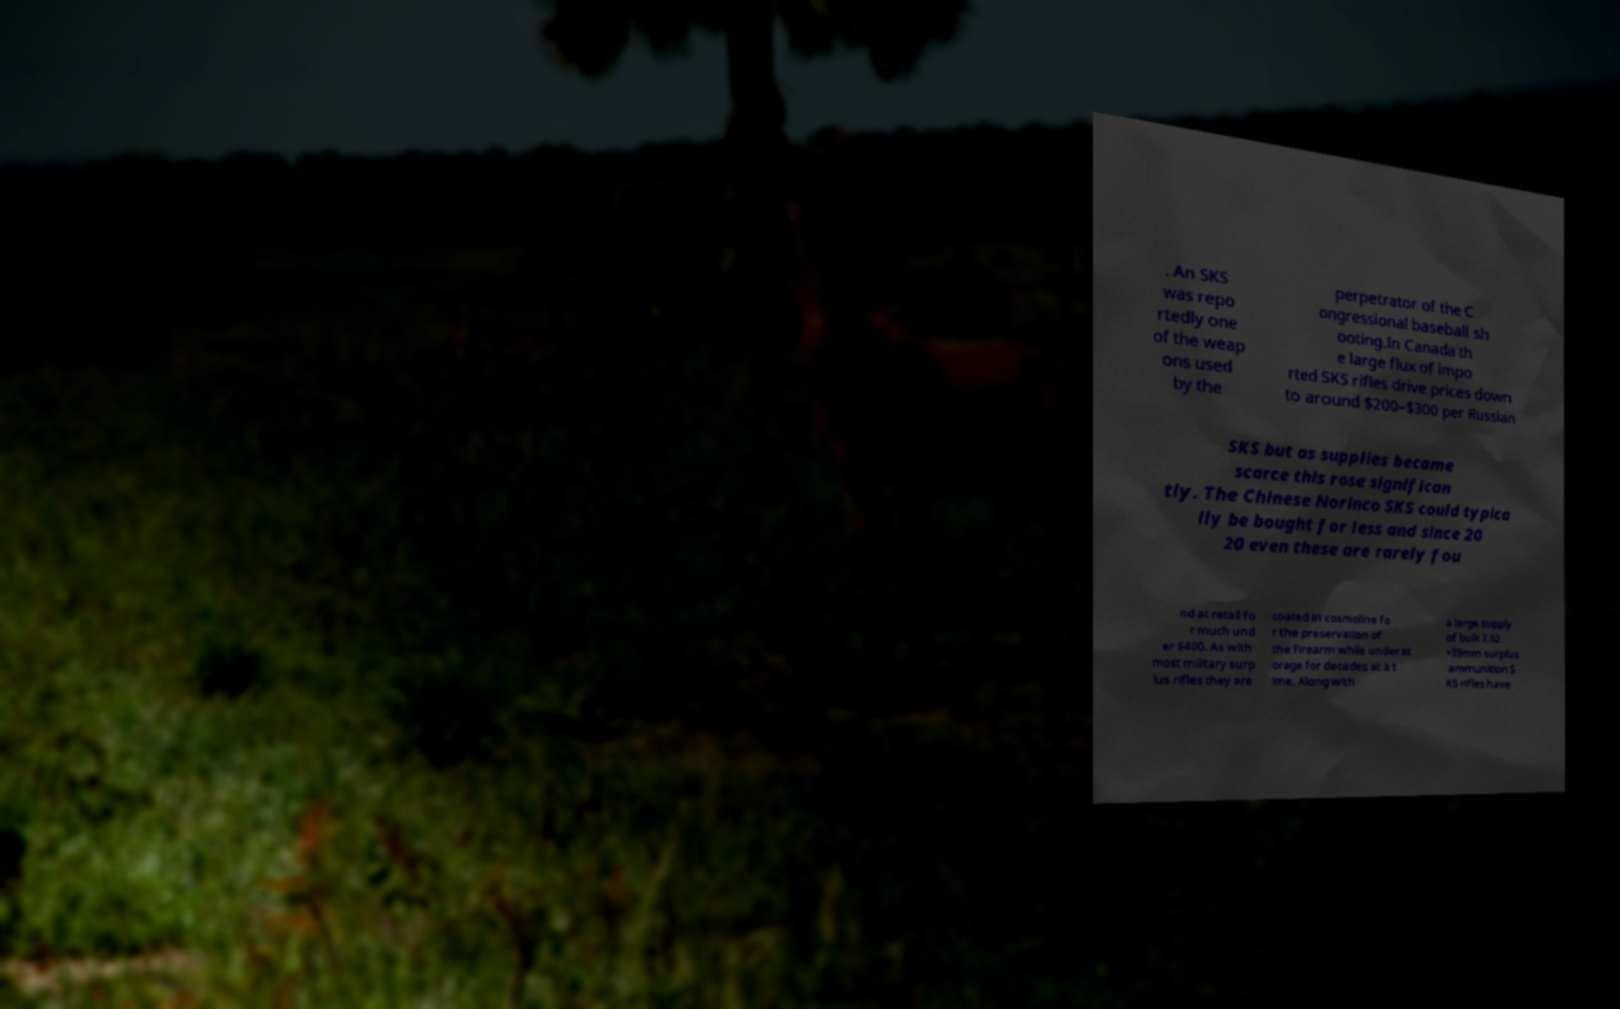For documentation purposes, I need the text within this image transcribed. Could you provide that? . An SKS was repo rtedly one of the weap ons used by the perpetrator of the C ongressional baseball sh ooting.In Canada th e large flux of impo rted SKS rifles drive prices down to around $200–$300 per Russian SKS but as supplies became scarce this rose significan tly. The Chinese Norinco SKS could typica lly be bought for less and since 20 20 even these are rarely fou nd at retail fo r much und er $400. As with most military surp lus rifles they are coated in cosmoline fo r the preservation of the firearm while under st orage for decades at a t ime. Along with a large supply of bulk 7.62 ×39mm surplus ammunition S KS rifles have 